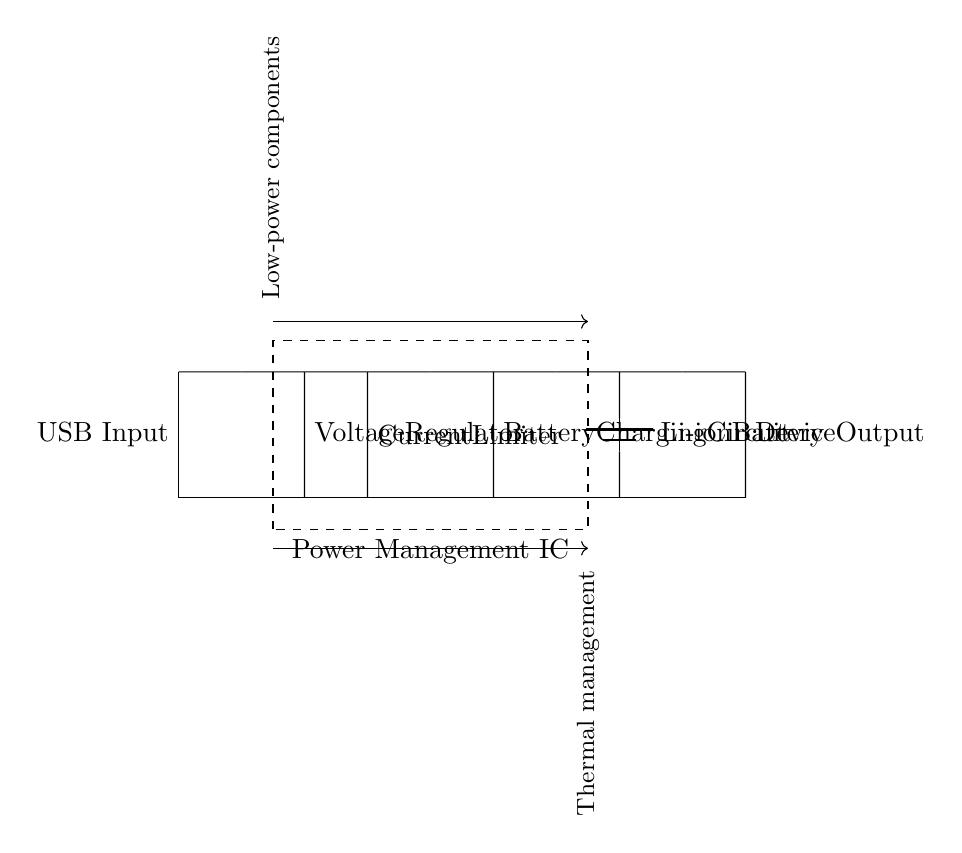what is the primary output component of the circuit? The primary output component in this circuit is the device output, where the energy from the battery is delivered to the portable device.
Answer: device output what type of battery is used in this circuit? The circuit indicates the usage of a lithium-ion battery, which is commonly chosen for energy efficiency and good performance in low power applications.
Answer: Li-ion battery how many main components are there in the circuit? The circuit diagram includes six main components: USB input, voltage regulator, current limiter, battery charging circuit, battery, and device output.
Answer: six what does the voltage regulator do in this circuit? The voltage regulator maintains a constant output voltage, ensuring that the connected devices receive stable power, even if the input voltage varies.
Answer: maintains voltage which component is responsible for protecting against overcurrent conditions? The current limiter is responsible for preventing excess current from flowing, protecting the circuit and connected components from damage caused by overcurrent.
Answer: current limiter describe the purpose of the power management IC. The power management IC integrates multiple functions such as voltage regulation, power distribution, and battery management within a compact form, optimizing the circuit's overall energy efficiency.
Answer: energy management what management aspect is indicated by the thermal management note in the circuit? The thermal management aspect involves regulating the temperature of the circuit components to prevent overheating, which is critical for ensuring reliability and performance in portable devices.
Answer: temperature regulation 